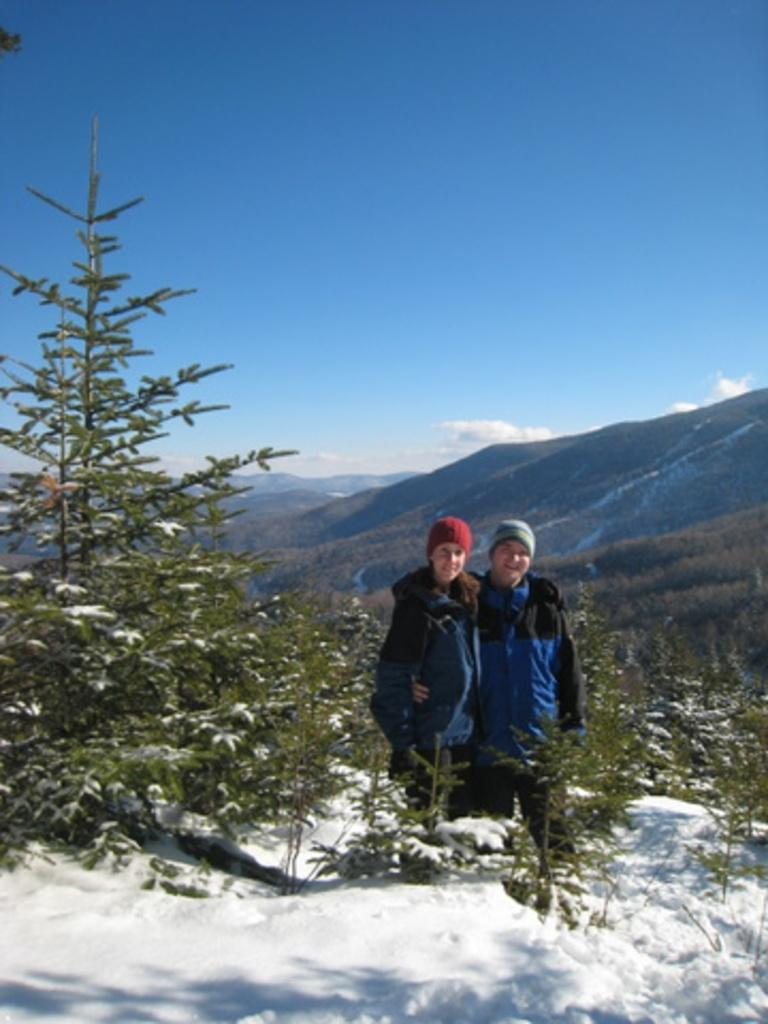What is located in the center of the image? There are plants in the center of the image. What are the people in the image doing? The persons standing in the image are smiling. What can be seen in the background of the image? There are mountains in the background of the image. What is the condition of the sky in the image? The sky is cloudy in the image. What type of creature can be seen interacting with the plants in the image? There is no creature interacting with the plants in the image; only the persons standing and smiling are present. Can you tell me how many circles are visible in the image? There are no circles present in the image. 